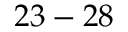<formula> <loc_0><loc_0><loc_500><loc_500>2 3 - 2 8</formula> 